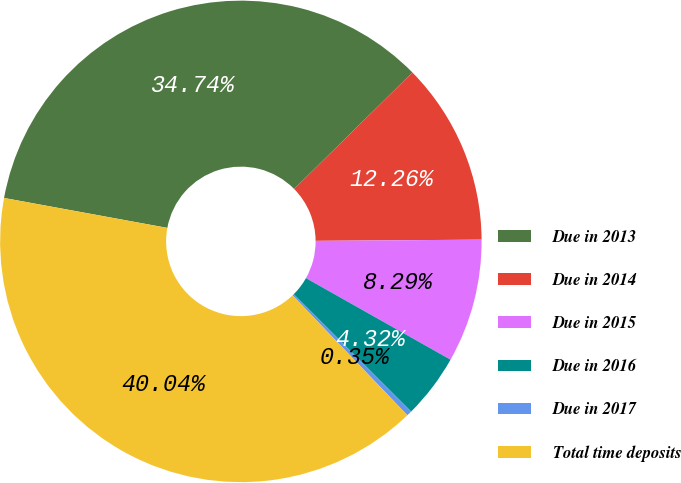<chart> <loc_0><loc_0><loc_500><loc_500><pie_chart><fcel>Due in 2013<fcel>Due in 2014<fcel>Due in 2015<fcel>Due in 2016<fcel>Due in 2017<fcel>Total time deposits<nl><fcel>34.74%<fcel>12.26%<fcel>8.29%<fcel>4.32%<fcel>0.35%<fcel>40.04%<nl></chart> 